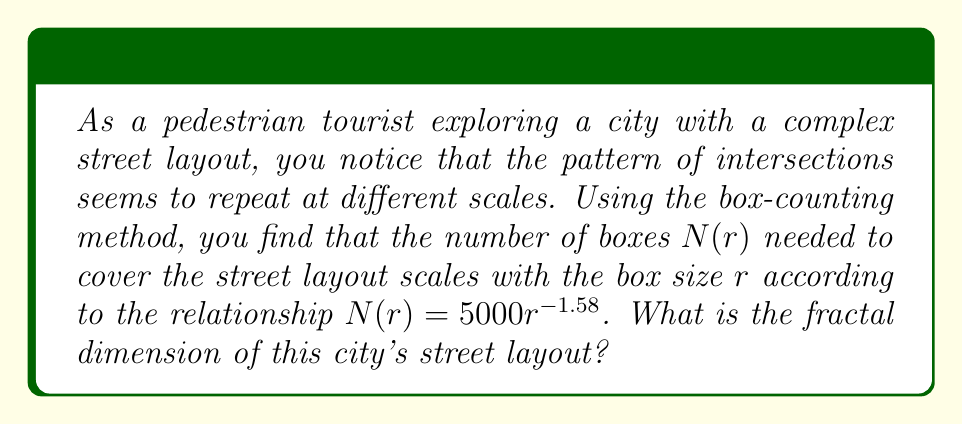Provide a solution to this math problem. To solve this problem, we'll follow these steps:

1) The box-counting dimension (which is a type of fractal dimension) is defined by the equation:

   $$D = -\lim_{r \to 0} \frac{\log N(r)}{\log r}$$

   where $N(r)$ is the number of boxes of side length $r$ needed to cover the set.

2) In our case, we're given that $N(r) = 5000r^{-1.58}$. Let's substitute this into our equation:

   $$D = -\lim_{r \to 0} \frac{\log (5000r^{-1.58})}{\log r}$$

3) Using the properties of logarithms, we can simplify:

   $$D = -\lim_{r \to 0} \frac{\log 5000 + \log r^{-1.58}}{\log r}$$

   $$D = -\lim_{r \to 0} \frac{\log 5000 - 1.58 \log r}{\log r}$$

4) As $r$ approaches 0, $\log r$ approaches negative infinity. Therefore, the $\log 5000$ term becomes negligible:

   $$D = -\lim_{r \to 0} \frac{- 1.58 \log r}{\log r}$$

5) The negative signs cancel out:

   $$D = \lim_{r \to 0} \frac{1.58 \log r}{\log r} = 1.58$$

Therefore, the fractal dimension of the city's street layout is 1.58.
Answer: 1.58 